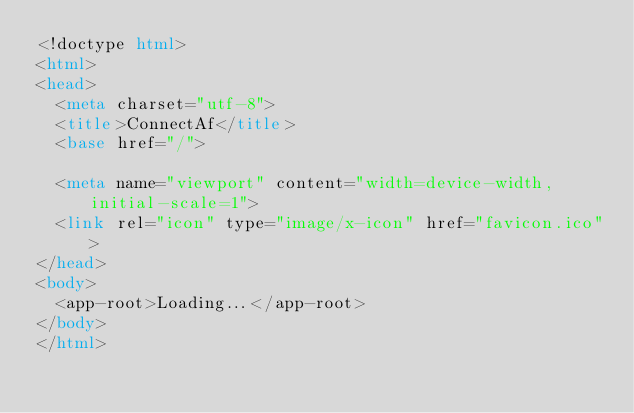Convert code to text. <code><loc_0><loc_0><loc_500><loc_500><_HTML_><!doctype html>
<html>
<head>
  <meta charset="utf-8">
  <title>ConnectAf</title>
  <base href="/">

  <meta name="viewport" content="width=device-width, initial-scale=1">
  <link rel="icon" type="image/x-icon" href="favicon.ico">
</head>
<body>
  <app-root>Loading...</app-root>
</body>
</html>
</code> 